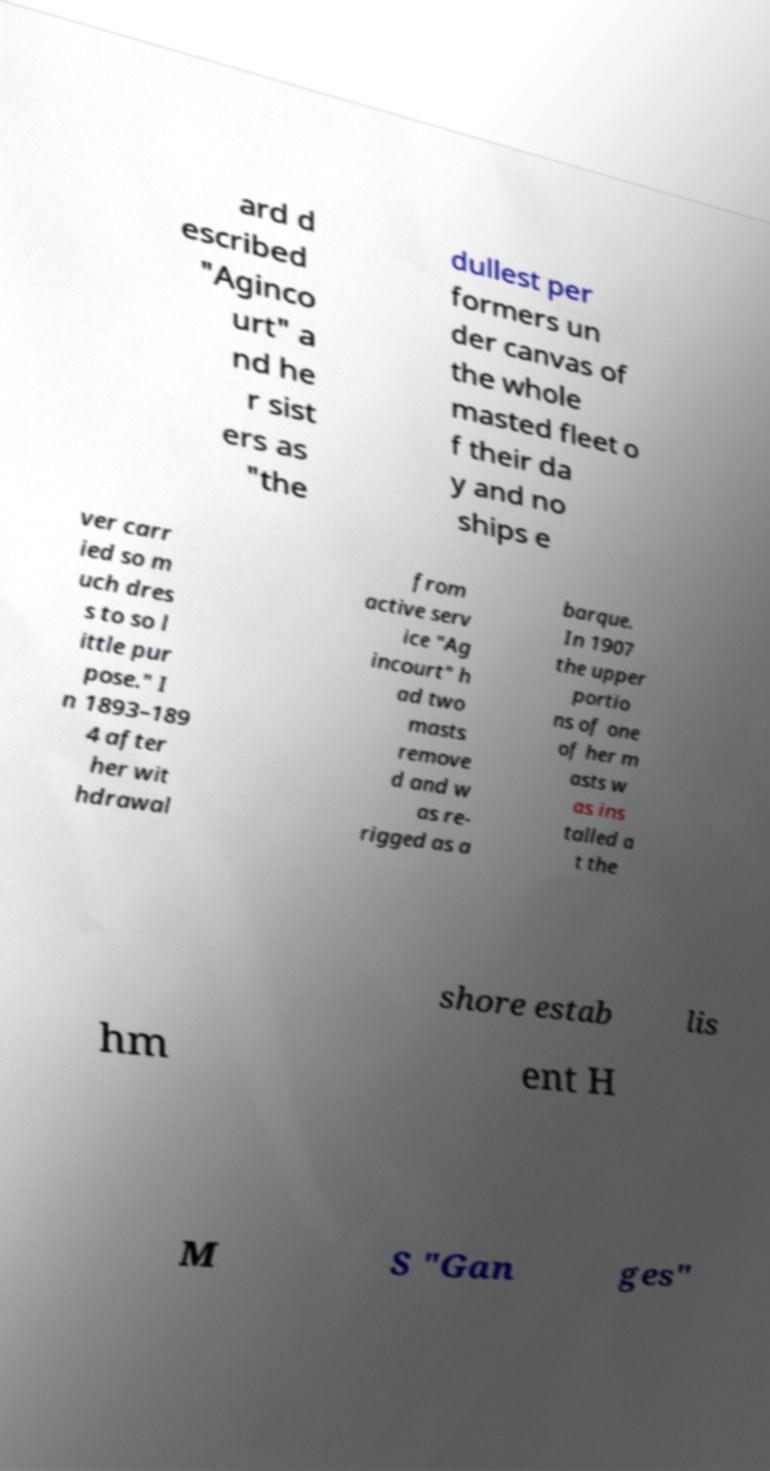Please read and relay the text visible in this image. What does it say? ard d escribed "Aginco urt" a nd he r sist ers as "the dullest per formers un der canvas of the whole masted fleet o f their da y and no ships e ver carr ied so m uch dres s to so l ittle pur pose." I n 1893–189 4 after her wit hdrawal from active serv ice "Ag incourt" h ad two masts remove d and w as re- rigged as a barque. In 1907 the upper portio ns of one of her m asts w as ins talled a t the shore estab lis hm ent H M S "Gan ges" 